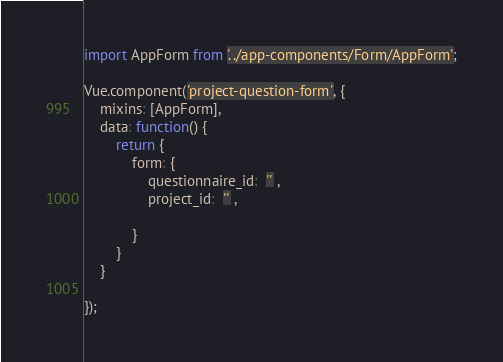Convert code to text. <code><loc_0><loc_0><loc_500><loc_500><_JavaScript_>import AppForm from '../app-components/Form/AppForm';

Vue.component('project-question-form', {
    mixins: [AppForm],
    data: function() {
        return {
            form: {
                questionnaire_id:  '' ,
                project_id:  '' ,
                
            }
        }
    }

});</code> 